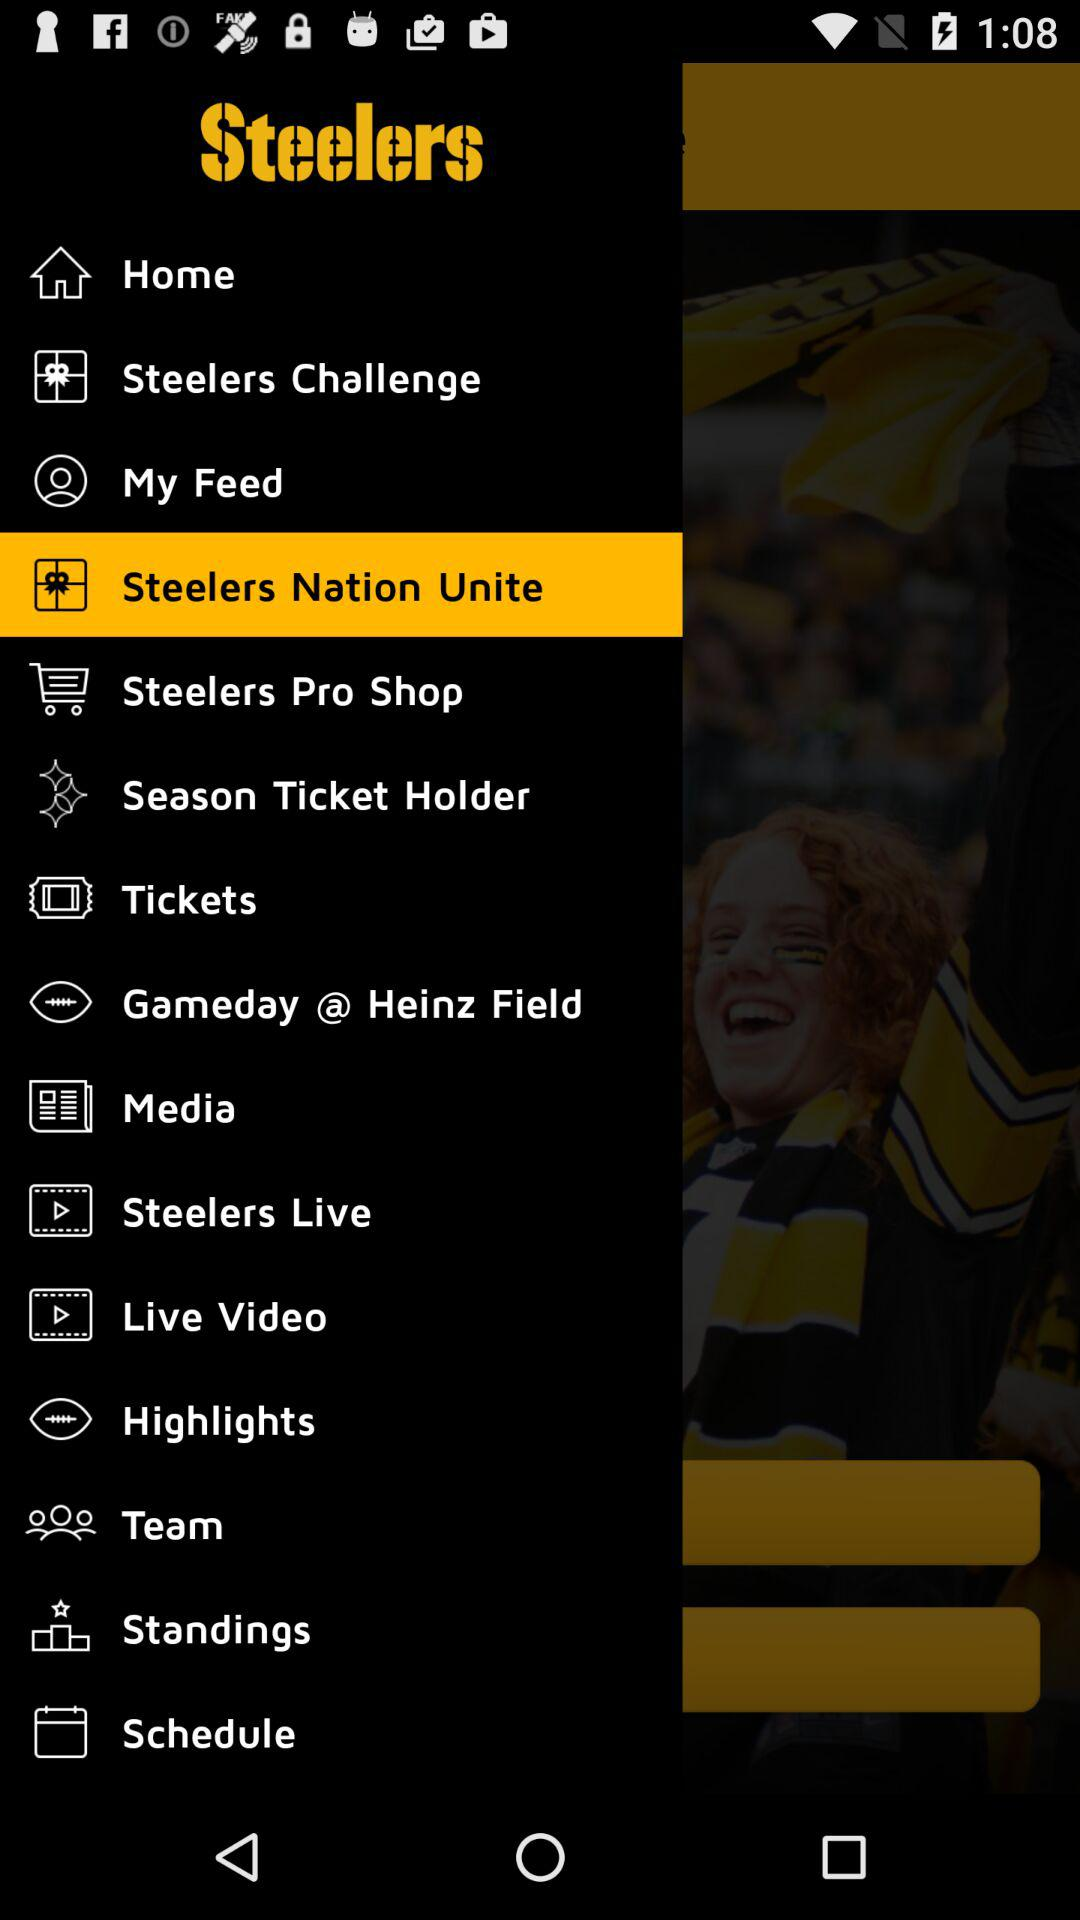What is the name of the application? The name of the application is "Steelers". 